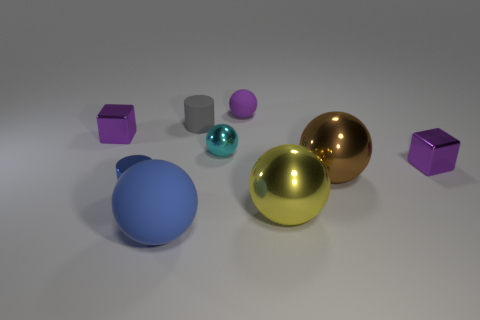Subtract all yellow shiny balls. How many balls are left? 4 Add 1 cyan metal cylinders. How many objects exist? 10 Subtract all cyan spheres. How many spheres are left? 4 Subtract 2 cubes. How many cubes are left? 0 Add 4 metallic objects. How many metallic objects are left? 10 Add 5 tiny purple spheres. How many tiny purple spheres exist? 6 Subtract 0 gray cubes. How many objects are left? 9 Subtract all spheres. How many objects are left? 4 Subtract all green cylinders. Subtract all green balls. How many cylinders are left? 2 Subtract all purple cylinders. How many yellow spheres are left? 1 